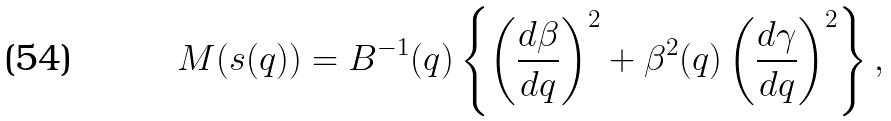<formula> <loc_0><loc_0><loc_500><loc_500>M ( s ( q ) ) = B ^ { - 1 } ( q ) \left \{ \left ( \frac { d \beta } { d q } \right ) ^ { 2 } + \beta ^ { 2 } ( q ) \left ( \frac { d \gamma } { d q } \right ) ^ { 2 } \right \} ,</formula> 